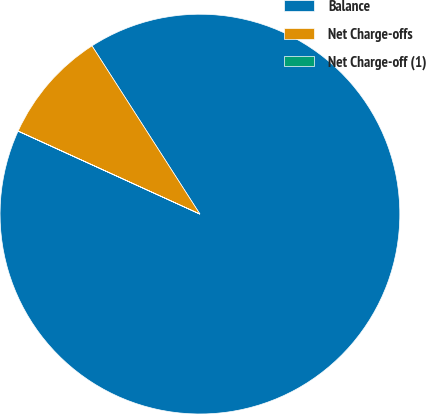<chart> <loc_0><loc_0><loc_500><loc_500><pie_chart><fcel>Balance<fcel>Net Charge-offs<fcel>Net Charge-off (1)<nl><fcel>90.89%<fcel>9.1%<fcel>0.01%<nl></chart> 